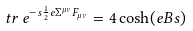<formula> <loc_0><loc_0><loc_500><loc_500>t r \, e ^ { - s \frac { 1 } { 2 } e \Sigma ^ { \mu \nu } F _ { \mu \nu } } = 4 \cosh ( e B s )</formula> 